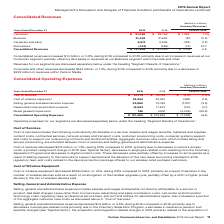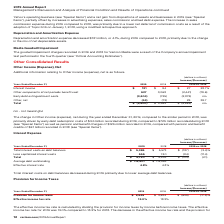According to Verizon Communications's financial document, What was the decrease in the cost of services in 2019? According to the financial document, $413 million. The relevant text states: "Cost of services decreased $413 million, or 1.3%, during 2019 compared to 2018, primarily due to decreases in network access costs, a produ..." Also, What caused the decrease in the cost of services? decreases in network access costs, a product realignment charge in 2018 (see “Special Items”), decreases in employee-related costs resulting from the Voluntary Separation Program and decreases in digital content costs. The document states: "%, during 2019 compared to 2018, primarily due to decreases in network access costs, a product realignment charge in 2018 (see “Special Items”), decre..." Also, What was the decrease in the cost of wireless equipment cost in 2019? According to the financial document, $369 million. The relevant text states: "Cost of wireless equipment decreased $369 million, or 1.6%, during 2019 compared to 2018, primarily as a result of declines in the number of wireless..." Also, can you calculate: What was the change in the cost of services from 2018 to 2019? Based on the calculation: 31,772 - 32,185, the result is -413 (in millions). This is based on the information: "Cost of services $ 31,772 $ 32,185 $ (413) (1.3)% Cost of services $ 31,772 $ 32,185 $ (413) (1.3)%..." The key data points involved are: 31,772, 32,185. Also, can you calculate: What was the average cost of wireless equipment for 2018 and 2019? To answer this question, I need to perform calculations using the financial data. The calculation is: (22,954 + 23,323) / 2, which equals 23138.5 (in millions). This is based on the information: "Cost of wireless equipment 22,954 23,323 (369) (1.6) Cost of wireless equipment 22,954 23,323 (369) (1.6)..." The key data points involved are: 22,954, 23,323. Also, can you calculate: What was the average Selling, general and administrative expense for 2018 and 2019? To answer this question, I need to perform calculations using the financial data. The calculation is: (29,896 + 31,083) / 2, which equals 30489.5 (in millions). This is based on the information: "elling, general and administrative expense 29,896 31,083 (1,187) (3.8) Selling, general and administrative expense 29,896 31,083 (1,187) (3.8)..." The key data points involved are: 29,896, 31,083. 